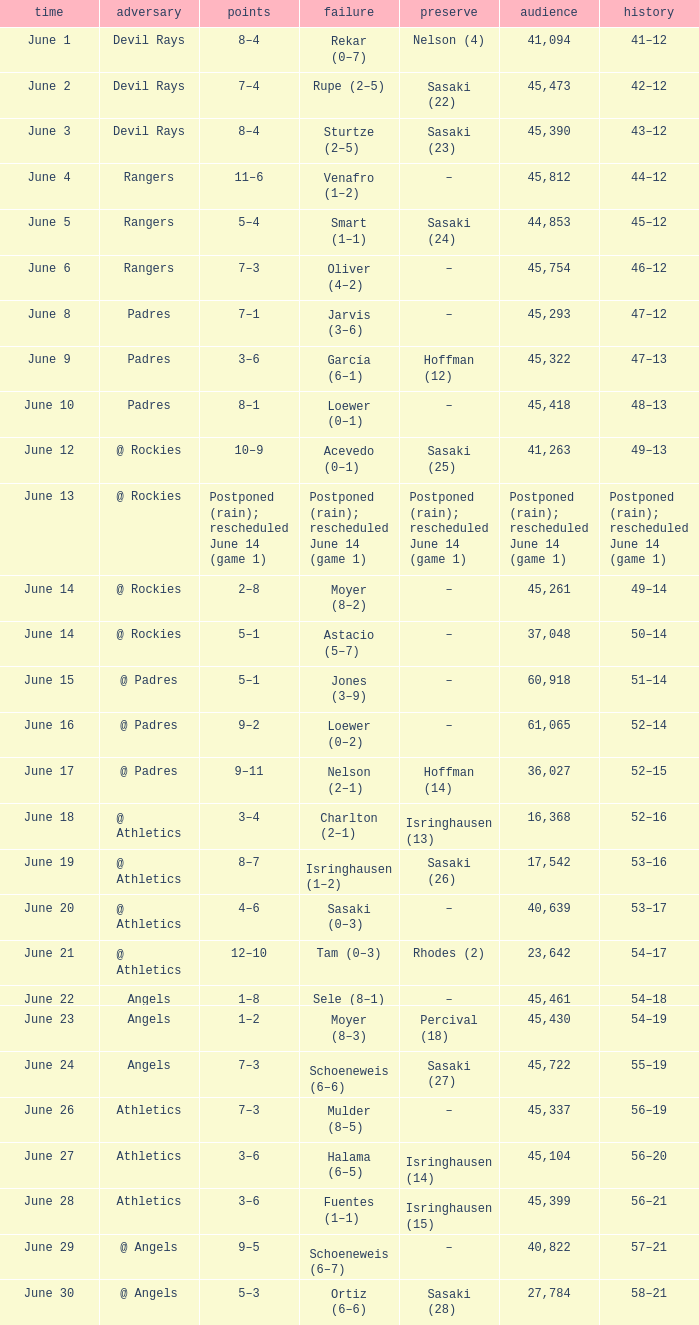Parse the full table. {'header': ['time', 'adversary', 'points', 'failure', 'preserve', 'audience', 'history'], 'rows': [['June 1', 'Devil Rays', '8–4', 'Rekar (0–7)', 'Nelson (4)', '41,094', '41–12'], ['June 2', 'Devil Rays', '7–4', 'Rupe (2–5)', 'Sasaki (22)', '45,473', '42–12'], ['June 3', 'Devil Rays', '8–4', 'Sturtze (2–5)', 'Sasaki (23)', '45,390', '43–12'], ['June 4', 'Rangers', '11–6', 'Venafro (1–2)', '–', '45,812', '44–12'], ['June 5', 'Rangers', '5–4', 'Smart (1–1)', 'Sasaki (24)', '44,853', '45–12'], ['June 6', 'Rangers', '7–3', 'Oliver (4–2)', '–', '45,754', '46–12'], ['June 8', 'Padres', '7–1', 'Jarvis (3–6)', '–', '45,293', '47–12'], ['June 9', 'Padres', '3–6', 'García (6–1)', 'Hoffman (12)', '45,322', '47–13'], ['June 10', 'Padres', '8–1', 'Loewer (0–1)', '–', '45,418', '48–13'], ['June 12', '@ Rockies', '10–9', 'Acevedo (0–1)', 'Sasaki (25)', '41,263', '49–13'], ['June 13', '@ Rockies', 'Postponed (rain); rescheduled June 14 (game 1)', 'Postponed (rain); rescheduled June 14 (game 1)', 'Postponed (rain); rescheduled June 14 (game 1)', 'Postponed (rain); rescheduled June 14 (game 1)', 'Postponed (rain); rescheduled June 14 (game 1)'], ['June 14', '@ Rockies', '2–8', 'Moyer (8–2)', '–', '45,261', '49–14'], ['June 14', '@ Rockies', '5–1', 'Astacio (5–7)', '–', '37,048', '50–14'], ['June 15', '@ Padres', '5–1', 'Jones (3–9)', '–', '60,918', '51–14'], ['June 16', '@ Padres', '9–2', 'Loewer (0–2)', '–', '61,065', '52–14'], ['June 17', '@ Padres', '9–11', 'Nelson (2–1)', 'Hoffman (14)', '36,027', '52–15'], ['June 18', '@ Athletics', '3–4', 'Charlton (2–1)', 'Isringhausen (13)', '16,368', '52–16'], ['June 19', '@ Athletics', '8–7', 'Isringhausen (1–2)', 'Sasaki (26)', '17,542', '53–16'], ['June 20', '@ Athletics', '4–6', 'Sasaki (0–3)', '–', '40,639', '53–17'], ['June 21', '@ Athletics', '12–10', 'Tam (0–3)', 'Rhodes (2)', '23,642', '54–17'], ['June 22', 'Angels', '1–8', 'Sele (8–1)', '–', '45,461', '54–18'], ['June 23', 'Angels', '1–2', 'Moyer (8–3)', 'Percival (18)', '45,430', '54–19'], ['June 24', 'Angels', '7–3', 'Schoeneweis (6–6)', 'Sasaki (27)', '45,722', '55–19'], ['June 26', 'Athletics', '7–3', 'Mulder (8–5)', '–', '45,337', '56–19'], ['June 27', 'Athletics', '3–6', 'Halama (6–5)', 'Isringhausen (14)', '45,104', '56–20'], ['June 28', 'Athletics', '3–6', 'Fuentes (1–1)', 'Isringhausen (15)', '45,399', '56–21'], ['June 29', '@ Angels', '9–5', 'Schoeneweis (6–7)', '–', '40,822', '57–21'], ['June 30', '@ Angels', '5–3', 'Ortiz (6–6)', 'Sasaki (28)', '27,784', '58–21']]} What was the score of the Mariners game when they had a record of 56–21? 3–6. 